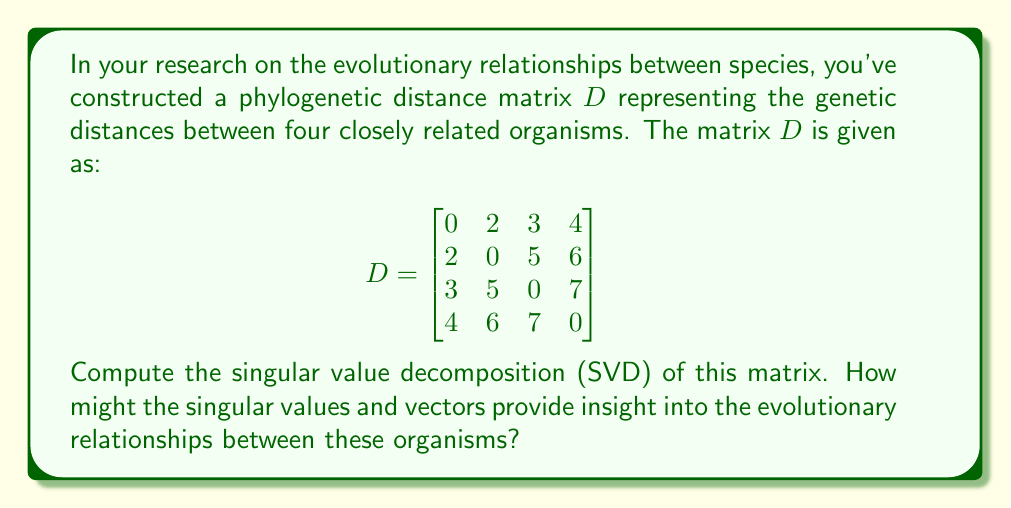Give your solution to this math problem. To compute the singular value decomposition (SVD) of the phylogenetic distance matrix $D$, we follow these steps:

1) First, we need to compute $D^TD$ and $DD^T$:

   $$D^TD = DD^T = \begin{bmatrix}
   29 & 34 & 43 & 52 \\
   34 & 65 & 64 & 78 \\
   43 & 64 & 83 & 98 \\
   52 & 78 & 98 & 121
   \end{bmatrix}$$

2) Calculate the eigenvalues of $D^TD$ (or $DD^T$):
   Solving the characteristic equation $\det(D^TD - \lambda I) = 0$, we get:
   $\lambda_1 \approx 292.8$, $\lambda_2 \approx 5.2$, $\lambda_3 = \lambda_4 = 0$

3) The singular values are the square roots of these eigenvalues:
   $\sigma_1 \approx 17.11$, $\sigma_2 \approx 2.28$, $\sigma_3 = \sigma_4 = 0$

4) Compute the right singular vectors (eigenvectors of $D^TD$):
   $v_1 \approx [0.2773, 0.5301, 0.6368, 0.7435]^T$
   $v_2 \approx [-0.6742, -0.3371, 0.4494, 0.4742]^T$
   $v_3$ and $v_4$ can be any orthonormal vectors in the nullspace of $D^TD$

5) Compute the left singular vectors:
   $u_i = \frac{1}{\sigma_i}Dv_i$ for $i = 1, 2$
   $u_1 \approx [0.2773, 0.5301, 0.6368, 0.7435]^T$
   $u_2 \approx [-0.6742, -0.3371, 0.4494, 0.4742]^T$
   $u_3$ and $u_4$ can be any orthonormal vectors in the nullspace of $DD^T$

Thus, the SVD of $D$ is $D = U\Sigma V^T$, where:

$$U = [u_1 | u_2 | u_3 | u_4]$$
$$\Sigma = \text{diag}(17.11, 2.28, 0, 0)$$
$$V = [v_1 | v_2 | v_3 | v_4]$$

Interpretation: The singular values represent the importance of different dimensions in the phylogenetic space. The largest singular value ($\sigma_1$) corresponds to the most significant dimension of variation, possibly representing the primary axis of evolutionary divergence. The corresponding singular vectors ($u_1$ and $v_1$) indicate how each organism contributes to this primary axis. The second singular value and its vectors represent a secondary, less important axis of variation. The zero singular values suggest that the four organisms can be accurately represented in a two-dimensional evolutionary space.
Answer: $D = U\Sigma V^T$, where $U \approx [u_1|u_2|u_3|u_4]$, $\Sigma \approx \text{diag}(17.11, 2.28, 0, 0)$, $V \approx [v_1|v_2|v_3|v_4]$, with $u_1 \approx v_1 \approx [0.2773, 0.5301, 0.6368, 0.7435]^T$ and $u_2 \approx v_2 \approx [-0.6742, -0.3371, 0.4494, 0.4742]^T$. 